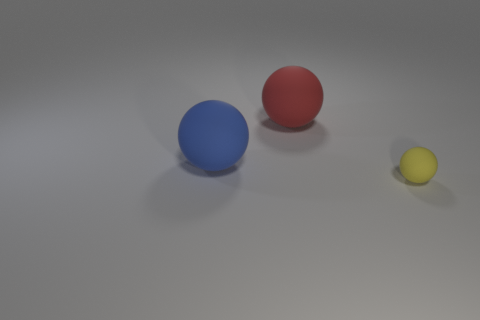There is a yellow object that is the same shape as the big blue thing; what is its size?
Give a very brief answer. Small. Is the number of large blue objects less than the number of cyan metallic spheres?
Offer a terse response. No. Is the material of the small object in front of the red object the same as the big red thing?
Your answer should be very brief. Yes. What is the big ball that is behind the blue rubber object made of?
Provide a short and direct response. Rubber. How big is the rubber object that is on the left side of the sphere that is behind the large blue matte sphere?
Your answer should be very brief. Large. Is there a small purple cube made of the same material as the tiny yellow ball?
Make the answer very short. No. There is a big ball right of the large blue rubber thing; does it have the same color as the large object left of the large red rubber sphere?
Give a very brief answer. No. Is there any other thing that is the same size as the yellow rubber object?
Provide a succinct answer. No. Are there any big matte spheres to the left of the red object?
Ensure brevity in your answer.  Yes. How many big red things are the same shape as the tiny yellow matte object?
Ensure brevity in your answer.  1. 